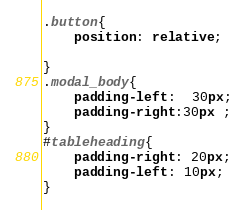Convert code to text. <code><loc_0><loc_0><loc_500><loc_500><_CSS_>.button{
    position: relative;
   
}
.modal_body{
    padding-left:  30px;
    padding-right:30px ;
}
#tableheading{
    padding-right: 20px;
    padding-left: 10px;
}
</code> 